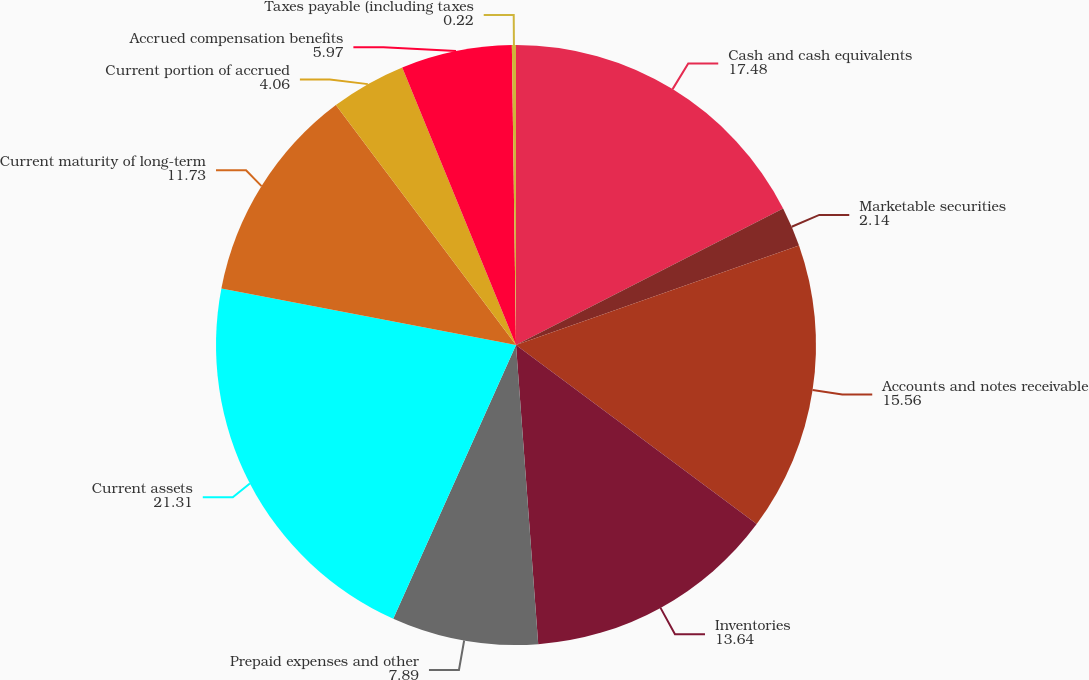<chart> <loc_0><loc_0><loc_500><loc_500><pie_chart><fcel>Cash and cash equivalents<fcel>Marketable securities<fcel>Accounts and notes receivable<fcel>Inventories<fcel>Prepaid expenses and other<fcel>Current assets<fcel>Current maturity of long-term<fcel>Current portion of accrued<fcel>Accrued compensation benefits<fcel>Taxes payable (including taxes<nl><fcel>17.48%<fcel>2.14%<fcel>15.56%<fcel>13.64%<fcel>7.89%<fcel>21.31%<fcel>11.73%<fcel>4.06%<fcel>5.97%<fcel>0.22%<nl></chart> 